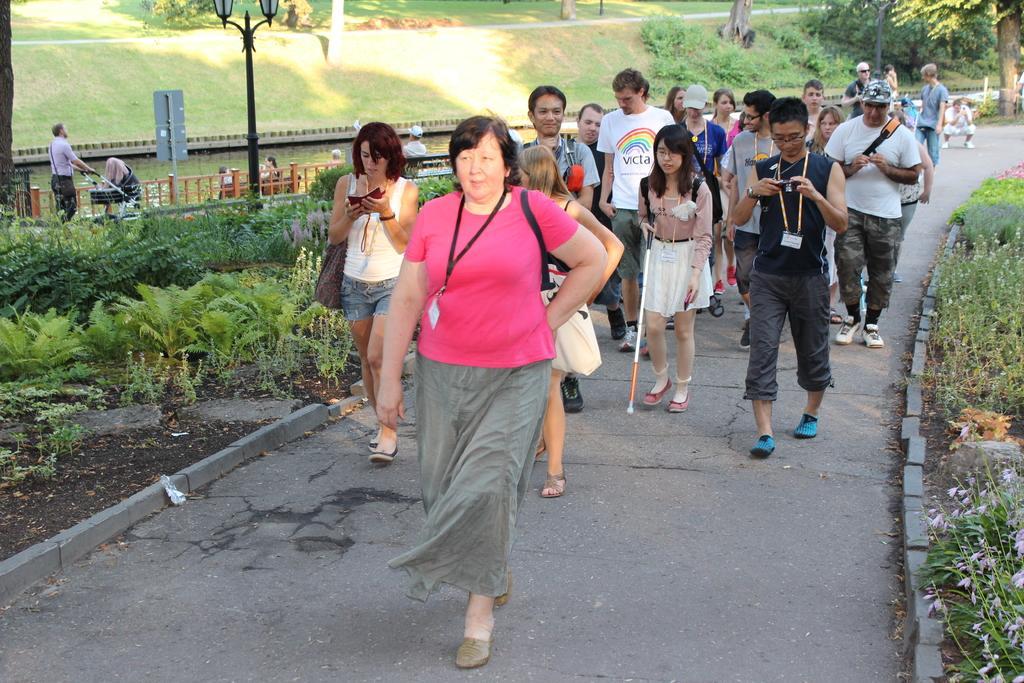Please provide a concise description of this image. In this picture we can see a group of people walking on the road, plants and in the background we can see a man holding a stroller with his hands, some people sitting on benches, light pole, fence, grass, water and trees. 